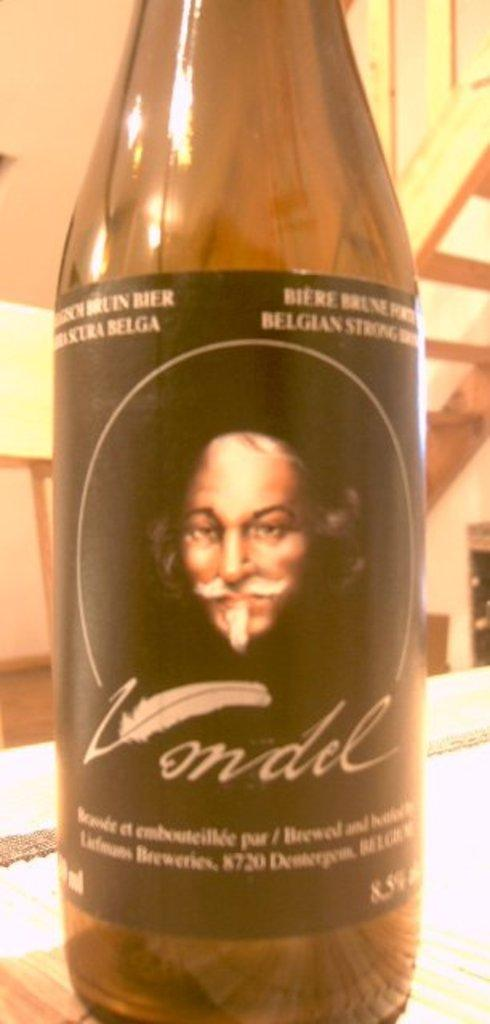<image>
Provide a brief description of the given image. The Vondel wine bottle's label contains an image of an old, bald, mustached white man. 